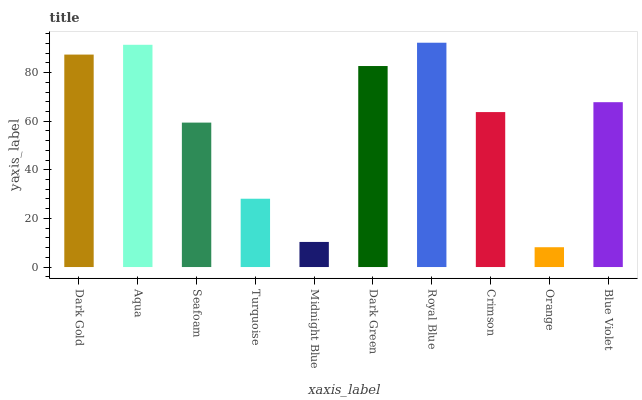Is Orange the minimum?
Answer yes or no. Yes. Is Royal Blue the maximum?
Answer yes or no. Yes. Is Aqua the minimum?
Answer yes or no. No. Is Aqua the maximum?
Answer yes or no. No. Is Aqua greater than Dark Gold?
Answer yes or no. Yes. Is Dark Gold less than Aqua?
Answer yes or no. Yes. Is Dark Gold greater than Aqua?
Answer yes or no. No. Is Aqua less than Dark Gold?
Answer yes or no. No. Is Blue Violet the high median?
Answer yes or no. Yes. Is Crimson the low median?
Answer yes or no. Yes. Is Dark Gold the high median?
Answer yes or no. No. Is Dark Gold the low median?
Answer yes or no. No. 